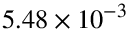<formula> <loc_0><loc_0><loc_500><loc_500>5 . 4 8 \times 1 0 ^ { - 3 }</formula> 